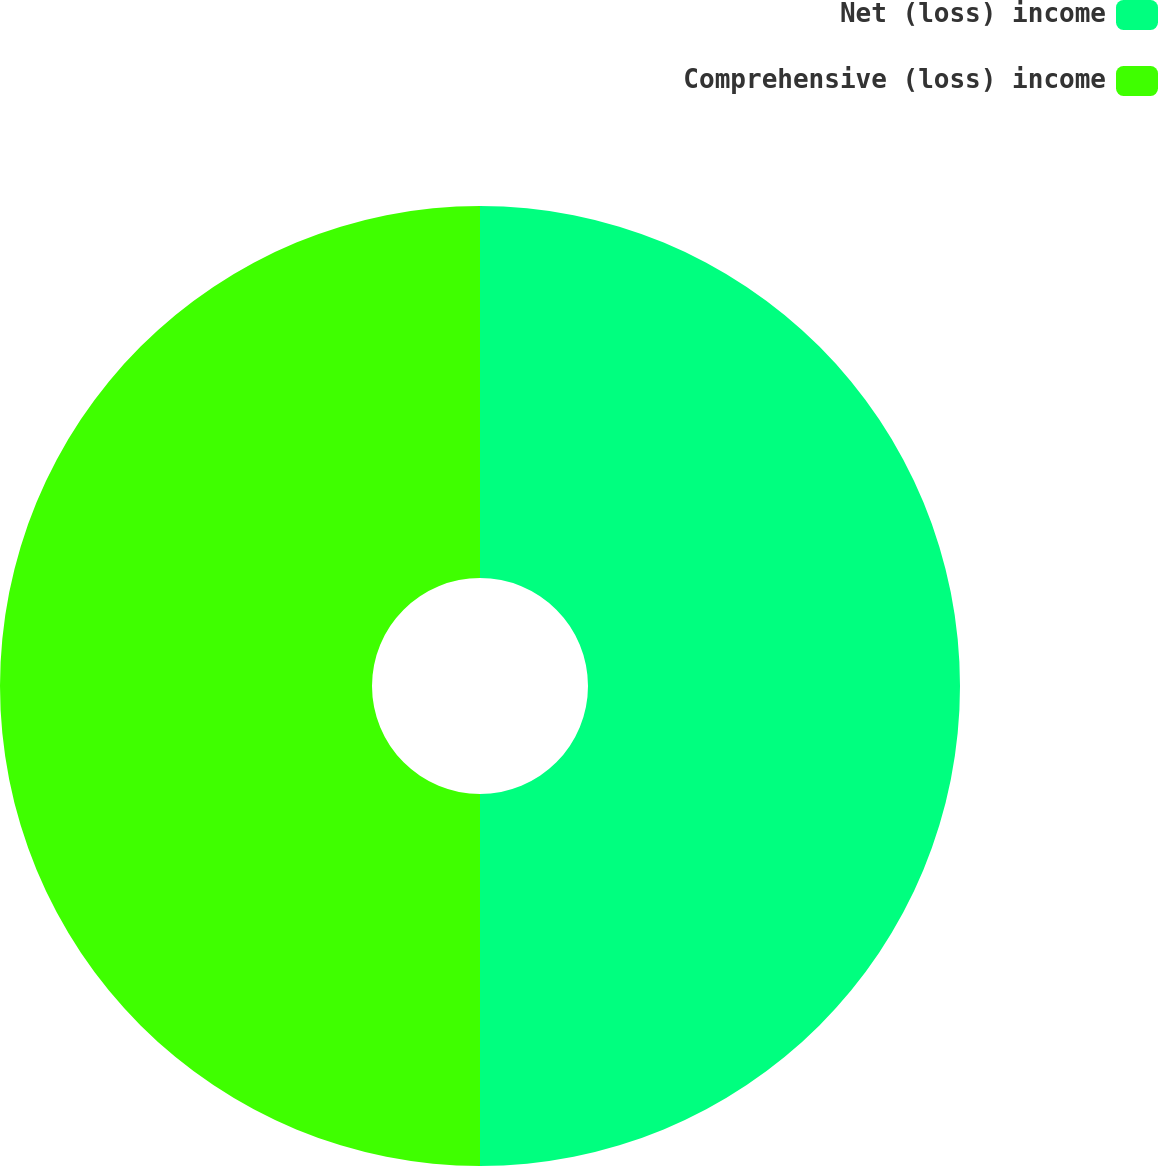Convert chart. <chart><loc_0><loc_0><loc_500><loc_500><pie_chart><fcel>Net (loss) income<fcel>Comprehensive (loss) income<nl><fcel>50.0%<fcel>50.0%<nl></chart> 